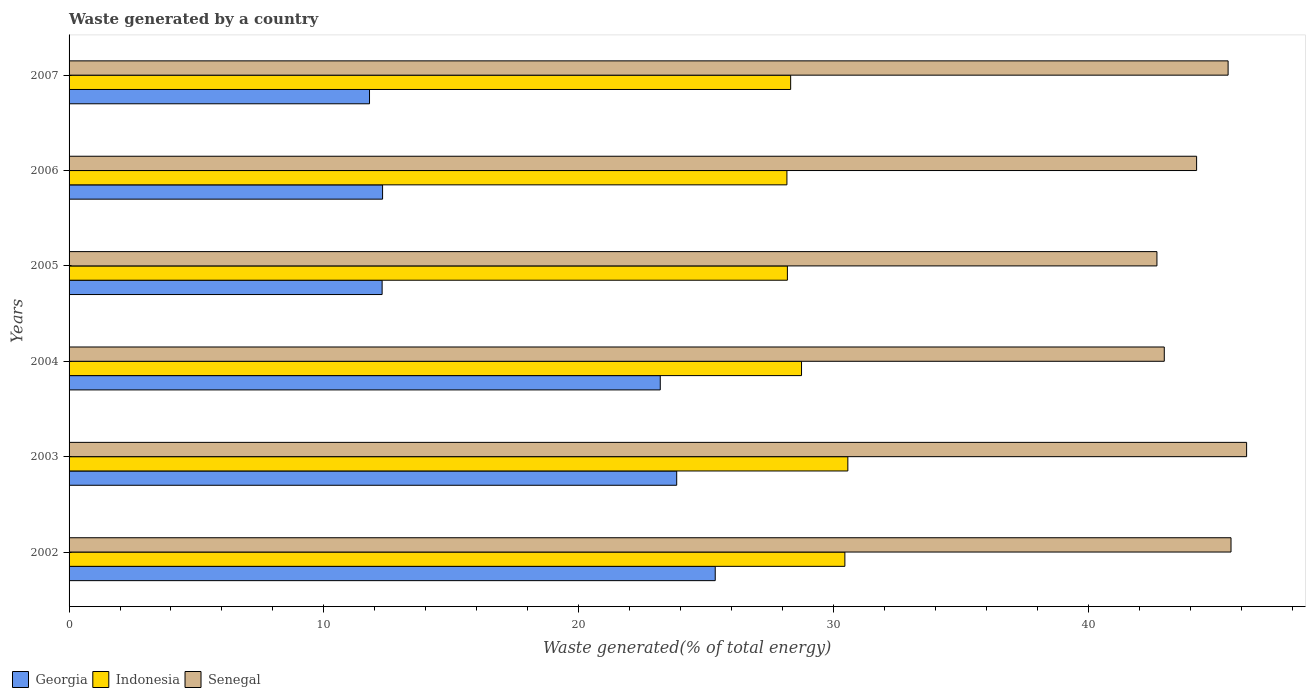Are the number of bars on each tick of the Y-axis equal?
Make the answer very short. Yes. What is the label of the 3rd group of bars from the top?
Provide a short and direct response. 2005. In how many cases, is the number of bars for a given year not equal to the number of legend labels?
Offer a terse response. 0. What is the total waste generated in Georgia in 2003?
Your response must be concise. 23.85. Across all years, what is the maximum total waste generated in Senegal?
Keep it short and to the point. 46.22. Across all years, what is the minimum total waste generated in Indonesia?
Offer a terse response. 28.17. In which year was the total waste generated in Senegal minimum?
Your response must be concise. 2005. What is the total total waste generated in Senegal in the graph?
Make the answer very short. 267.24. What is the difference between the total waste generated in Senegal in 2005 and that in 2007?
Give a very brief answer. -2.79. What is the difference between the total waste generated in Indonesia in 2003 and the total waste generated in Georgia in 2002?
Offer a terse response. 5.2. What is the average total waste generated in Indonesia per year?
Provide a short and direct response. 29.07. In the year 2003, what is the difference between the total waste generated in Indonesia and total waste generated in Senegal?
Give a very brief answer. -15.65. In how many years, is the total waste generated in Indonesia greater than 2 %?
Your answer should be compact. 6. What is the ratio of the total waste generated in Senegal in 2002 to that in 2007?
Provide a succinct answer. 1. Is the difference between the total waste generated in Indonesia in 2002 and 2007 greater than the difference between the total waste generated in Senegal in 2002 and 2007?
Give a very brief answer. Yes. What is the difference between the highest and the second highest total waste generated in Georgia?
Your answer should be compact. 1.51. What is the difference between the highest and the lowest total waste generated in Georgia?
Offer a very short reply. 13.57. In how many years, is the total waste generated in Indonesia greater than the average total waste generated in Indonesia taken over all years?
Your answer should be compact. 2. What does the 3rd bar from the top in 2005 represents?
Ensure brevity in your answer.  Georgia. What does the 3rd bar from the bottom in 2004 represents?
Your answer should be compact. Senegal. Are all the bars in the graph horizontal?
Offer a terse response. Yes. What is the difference between two consecutive major ticks on the X-axis?
Give a very brief answer. 10. Are the values on the major ticks of X-axis written in scientific E-notation?
Make the answer very short. No. Does the graph contain any zero values?
Ensure brevity in your answer.  No. How many legend labels are there?
Offer a terse response. 3. How are the legend labels stacked?
Provide a succinct answer. Horizontal. What is the title of the graph?
Your answer should be very brief. Waste generated by a country. What is the label or title of the X-axis?
Keep it short and to the point. Waste generated(% of total energy). What is the label or title of the Y-axis?
Your answer should be compact. Years. What is the Waste generated(% of total energy) in Georgia in 2002?
Provide a short and direct response. 25.36. What is the Waste generated(% of total energy) in Indonesia in 2002?
Your answer should be compact. 30.45. What is the Waste generated(% of total energy) of Senegal in 2002?
Offer a terse response. 45.6. What is the Waste generated(% of total energy) of Georgia in 2003?
Your response must be concise. 23.85. What is the Waste generated(% of total energy) of Indonesia in 2003?
Make the answer very short. 30.57. What is the Waste generated(% of total energy) in Senegal in 2003?
Offer a very short reply. 46.22. What is the Waste generated(% of total energy) in Georgia in 2004?
Offer a very short reply. 23.2. What is the Waste generated(% of total energy) of Indonesia in 2004?
Offer a very short reply. 28.75. What is the Waste generated(% of total energy) of Senegal in 2004?
Offer a very short reply. 42.99. What is the Waste generated(% of total energy) in Georgia in 2005?
Offer a terse response. 12.29. What is the Waste generated(% of total energy) in Indonesia in 2005?
Offer a very short reply. 28.19. What is the Waste generated(% of total energy) of Senegal in 2005?
Offer a very short reply. 42.7. What is the Waste generated(% of total energy) of Georgia in 2006?
Offer a very short reply. 12.3. What is the Waste generated(% of total energy) in Indonesia in 2006?
Offer a terse response. 28.17. What is the Waste generated(% of total energy) in Senegal in 2006?
Ensure brevity in your answer.  44.25. What is the Waste generated(% of total energy) of Georgia in 2007?
Your answer should be very brief. 11.79. What is the Waste generated(% of total energy) of Indonesia in 2007?
Make the answer very short. 28.32. What is the Waste generated(% of total energy) of Senegal in 2007?
Ensure brevity in your answer.  45.49. Across all years, what is the maximum Waste generated(% of total energy) of Georgia?
Your answer should be compact. 25.36. Across all years, what is the maximum Waste generated(% of total energy) in Indonesia?
Offer a terse response. 30.57. Across all years, what is the maximum Waste generated(% of total energy) of Senegal?
Your response must be concise. 46.22. Across all years, what is the minimum Waste generated(% of total energy) of Georgia?
Ensure brevity in your answer.  11.79. Across all years, what is the minimum Waste generated(% of total energy) in Indonesia?
Offer a very short reply. 28.17. Across all years, what is the minimum Waste generated(% of total energy) of Senegal?
Your answer should be very brief. 42.7. What is the total Waste generated(% of total energy) in Georgia in the graph?
Your answer should be very brief. 108.8. What is the total Waste generated(% of total energy) of Indonesia in the graph?
Keep it short and to the point. 174.45. What is the total Waste generated(% of total energy) in Senegal in the graph?
Ensure brevity in your answer.  267.25. What is the difference between the Waste generated(% of total energy) in Georgia in 2002 and that in 2003?
Ensure brevity in your answer.  1.51. What is the difference between the Waste generated(% of total energy) in Indonesia in 2002 and that in 2003?
Offer a very short reply. -0.12. What is the difference between the Waste generated(% of total energy) in Senegal in 2002 and that in 2003?
Your answer should be very brief. -0.61. What is the difference between the Waste generated(% of total energy) of Georgia in 2002 and that in 2004?
Your answer should be compact. 2.16. What is the difference between the Waste generated(% of total energy) in Indonesia in 2002 and that in 2004?
Provide a succinct answer. 1.7. What is the difference between the Waste generated(% of total energy) in Senegal in 2002 and that in 2004?
Give a very brief answer. 2.62. What is the difference between the Waste generated(% of total energy) in Georgia in 2002 and that in 2005?
Make the answer very short. 13.07. What is the difference between the Waste generated(% of total energy) in Indonesia in 2002 and that in 2005?
Provide a succinct answer. 2.26. What is the difference between the Waste generated(% of total energy) of Senegal in 2002 and that in 2005?
Keep it short and to the point. 2.91. What is the difference between the Waste generated(% of total energy) in Georgia in 2002 and that in 2006?
Provide a succinct answer. 13.06. What is the difference between the Waste generated(% of total energy) in Indonesia in 2002 and that in 2006?
Give a very brief answer. 2.27. What is the difference between the Waste generated(% of total energy) in Senegal in 2002 and that in 2006?
Offer a very short reply. 1.35. What is the difference between the Waste generated(% of total energy) of Georgia in 2002 and that in 2007?
Ensure brevity in your answer.  13.57. What is the difference between the Waste generated(% of total energy) of Indonesia in 2002 and that in 2007?
Keep it short and to the point. 2.13. What is the difference between the Waste generated(% of total energy) in Senegal in 2002 and that in 2007?
Offer a terse response. 0.11. What is the difference between the Waste generated(% of total energy) of Georgia in 2003 and that in 2004?
Make the answer very short. 0.65. What is the difference between the Waste generated(% of total energy) in Indonesia in 2003 and that in 2004?
Keep it short and to the point. 1.82. What is the difference between the Waste generated(% of total energy) of Senegal in 2003 and that in 2004?
Keep it short and to the point. 3.23. What is the difference between the Waste generated(% of total energy) in Georgia in 2003 and that in 2005?
Make the answer very short. 11.56. What is the difference between the Waste generated(% of total energy) in Indonesia in 2003 and that in 2005?
Ensure brevity in your answer.  2.37. What is the difference between the Waste generated(% of total energy) of Senegal in 2003 and that in 2005?
Give a very brief answer. 3.52. What is the difference between the Waste generated(% of total energy) in Georgia in 2003 and that in 2006?
Your answer should be very brief. 11.54. What is the difference between the Waste generated(% of total energy) in Indonesia in 2003 and that in 2006?
Your answer should be very brief. 2.39. What is the difference between the Waste generated(% of total energy) of Senegal in 2003 and that in 2006?
Make the answer very short. 1.96. What is the difference between the Waste generated(% of total energy) of Georgia in 2003 and that in 2007?
Your response must be concise. 12.06. What is the difference between the Waste generated(% of total energy) of Indonesia in 2003 and that in 2007?
Give a very brief answer. 2.24. What is the difference between the Waste generated(% of total energy) in Senegal in 2003 and that in 2007?
Your answer should be compact. 0.73. What is the difference between the Waste generated(% of total energy) in Georgia in 2004 and that in 2005?
Provide a short and direct response. 10.92. What is the difference between the Waste generated(% of total energy) of Indonesia in 2004 and that in 2005?
Make the answer very short. 0.56. What is the difference between the Waste generated(% of total energy) of Senegal in 2004 and that in 2005?
Make the answer very short. 0.29. What is the difference between the Waste generated(% of total energy) of Georgia in 2004 and that in 2006?
Your answer should be compact. 10.9. What is the difference between the Waste generated(% of total energy) in Indonesia in 2004 and that in 2006?
Provide a short and direct response. 0.57. What is the difference between the Waste generated(% of total energy) in Senegal in 2004 and that in 2006?
Ensure brevity in your answer.  -1.27. What is the difference between the Waste generated(% of total energy) of Georgia in 2004 and that in 2007?
Make the answer very short. 11.41. What is the difference between the Waste generated(% of total energy) of Indonesia in 2004 and that in 2007?
Provide a succinct answer. 0.43. What is the difference between the Waste generated(% of total energy) in Senegal in 2004 and that in 2007?
Provide a succinct answer. -2.5. What is the difference between the Waste generated(% of total energy) of Georgia in 2005 and that in 2006?
Give a very brief answer. -0.02. What is the difference between the Waste generated(% of total energy) of Indonesia in 2005 and that in 2006?
Ensure brevity in your answer.  0.02. What is the difference between the Waste generated(% of total energy) in Senegal in 2005 and that in 2006?
Make the answer very short. -1.56. What is the difference between the Waste generated(% of total energy) of Georgia in 2005 and that in 2007?
Ensure brevity in your answer.  0.49. What is the difference between the Waste generated(% of total energy) of Indonesia in 2005 and that in 2007?
Offer a terse response. -0.13. What is the difference between the Waste generated(% of total energy) in Senegal in 2005 and that in 2007?
Your answer should be compact. -2.79. What is the difference between the Waste generated(% of total energy) in Georgia in 2006 and that in 2007?
Offer a terse response. 0.51. What is the difference between the Waste generated(% of total energy) of Indonesia in 2006 and that in 2007?
Your answer should be very brief. -0.15. What is the difference between the Waste generated(% of total energy) of Senegal in 2006 and that in 2007?
Keep it short and to the point. -1.24. What is the difference between the Waste generated(% of total energy) in Georgia in 2002 and the Waste generated(% of total energy) in Indonesia in 2003?
Provide a short and direct response. -5.2. What is the difference between the Waste generated(% of total energy) in Georgia in 2002 and the Waste generated(% of total energy) in Senegal in 2003?
Keep it short and to the point. -20.86. What is the difference between the Waste generated(% of total energy) in Indonesia in 2002 and the Waste generated(% of total energy) in Senegal in 2003?
Provide a short and direct response. -15.77. What is the difference between the Waste generated(% of total energy) in Georgia in 2002 and the Waste generated(% of total energy) in Indonesia in 2004?
Ensure brevity in your answer.  -3.39. What is the difference between the Waste generated(% of total energy) of Georgia in 2002 and the Waste generated(% of total energy) of Senegal in 2004?
Make the answer very short. -17.62. What is the difference between the Waste generated(% of total energy) of Indonesia in 2002 and the Waste generated(% of total energy) of Senegal in 2004?
Ensure brevity in your answer.  -12.54. What is the difference between the Waste generated(% of total energy) in Georgia in 2002 and the Waste generated(% of total energy) in Indonesia in 2005?
Offer a terse response. -2.83. What is the difference between the Waste generated(% of total energy) of Georgia in 2002 and the Waste generated(% of total energy) of Senegal in 2005?
Your answer should be compact. -17.34. What is the difference between the Waste generated(% of total energy) of Indonesia in 2002 and the Waste generated(% of total energy) of Senegal in 2005?
Make the answer very short. -12.25. What is the difference between the Waste generated(% of total energy) in Georgia in 2002 and the Waste generated(% of total energy) in Indonesia in 2006?
Your response must be concise. -2.81. What is the difference between the Waste generated(% of total energy) of Georgia in 2002 and the Waste generated(% of total energy) of Senegal in 2006?
Ensure brevity in your answer.  -18.89. What is the difference between the Waste generated(% of total energy) in Indonesia in 2002 and the Waste generated(% of total energy) in Senegal in 2006?
Your answer should be very brief. -13.8. What is the difference between the Waste generated(% of total energy) in Georgia in 2002 and the Waste generated(% of total energy) in Indonesia in 2007?
Your answer should be very brief. -2.96. What is the difference between the Waste generated(% of total energy) of Georgia in 2002 and the Waste generated(% of total energy) of Senegal in 2007?
Make the answer very short. -20.13. What is the difference between the Waste generated(% of total energy) of Indonesia in 2002 and the Waste generated(% of total energy) of Senegal in 2007?
Give a very brief answer. -15.04. What is the difference between the Waste generated(% of total energy) of Georgia in 2003 and the Waste generated(% of total energy) of Indonesia in 2004?
Your response must be concise. -4.9. What is the difference between the Waste generated(% of total energy) of Georgia in 2003 and the Waste generated(% of total energy) of Senegal in 2004?
Your response must be concise. -19.14. What is the difference between the Waste generated(% of total energy) of Indonesia in 2003 and the Waste generated(% of total energy) of Senegal in 2004?
Ensure brevity in your answer.  -12.42. What is the difference between the Waste generated(% of total energy) in Georgia in 2003 and the Waste generated(% of total energy) in Indonesia in 2005?
Keep it short and to the point. -4.34. What is the difference between the Waste generated(% of total energy) of Georgia in 2003 and the Waste generated(% of total energy) of Senegal in 2005?
Ensure brevity in your answer.  -18.85. What is the difference between the Waste generated(% of total energy) in Indonesia in 2003 and the Waste generated(% of total energy) in Senegal in 2005?
Provide a succinct answer. -12.13. What is the difference between the Waste generated(% of total energy) of Georgia in 2003 and the Waste generated(% of total energy) of Indonesia in 2006?
Your answer should be compact. -4.33. What is the difference between the Waste generated(% of total energy) of Georgia in 2003 and the Waste generated(% of total energy) of Senegal in 2006?
Offer a very short reply. -20.41. What is the difference between the Waste generated(% of total energy) of Indonesia in 2003 and the Waste generated(% of total energy) of Senegal in 2006?
Provide a short and direct response. -13.69. What is the difference between the Waste generated(% of total energy) of Georgia in 2003 and the Waste generated(% of total energy) of Indonesia in 2007?
Give a very brief answer. -4.47. What is the difference between the Waste generated(% of total energy) of Georgia in 2003 and the Waste generated(% of total energy) of Senegal in 2007?
Offer a very short reply. -21.64. What is the difference between the Waste generated(% of total energy) in Indonesia in 2003 and the Waste generated(% of total energy) in Senegal in 2007?
Your answer should be very brief. -14.92. What is the difference between the Waste generated(% of total energy) of Georgia in 2004 and the Waste generated(% of total energy) of Indonesia in 2005?
Make the answer very short. -4.99. What is the difference between the Waste generated(% of total energy) in Georgia in 2004 and the Waste generated(% of total energy) in Senegal in 2005?
Offer a terse response. -19.49. What is the difference between the Waste generated(% of total energy) in Indonesia in 2004 and the Waste generated(% of total energy) in Senegal in 2005?
Your answer should be very brief. -13.95. What is the difference between the Waste generated(% of total energy) in Georgia in 2004 and the Waste generated(% of total energy) in Indonesia in 2006?
Offer a very short reply. -4.97. What is the difference between the Waste generated(% of total energy) in Georgia in 2004 and the Waste generated(% of total energy) in Senegal in 2006?
Offer a very short reply. -21.05. What is the difference between the Waste generated(% of total energy) in Indonesia in 2004 and the Waste generated(% of total energy) in Senegal in 2006?
Keep it short and to the point. -15.51. What is the difference between the Waste generated(% of total energy) of Georgia in 2004 and the Waste generated(% of total energy) of Indonesia in 2007?
Your answer should be compact. -5.12. What is the difference between the Waste generated(% of total energy) of Georgia in 2004 and the Waste generated(% of total energy) of Senegal in 2007?
Offer a terse response. -22.29. What is the difference between the Waste generated(% of total energy) of Indonesia in 2004 and the Waste generated(% of total energy) of Senegal in 2007?
Your answer should be very brief. -16.74. What is the difference between the Waste generated(% of total energy) of Georgia in 2005 and the Waste generated(% of total energy) of Indonesia in 2006?
Offer a terse response. -15.89. What is the difference between the Waste generated(% of total energy) in Georgia in 2005 and the Waste generated(% of total energy) in Senegal in 2006?
Your response must be concise. -31.97. What is the difference between the Waste generated(% of total energy) in Indonesia in 2005 and the Waste generated(% of total energy) in Senegal in 2006?
Provide a succinct answer. -16.06. What is the difference between the Waste generated(% of total energy) of Georgia in 2005 and the Waste generated(% of total energy) of Indonesia in 2007?
Make the answer very short. -16.03. What is the difference between the Waste generated(% of total energy) in Georgia in 2005 and the Waste generated(% of total energy) in Senegal in 2007?
Provide a succinct answer. -33.2. What is the difference between the Waste generated(% of total energy) in Indonesia in 2005 and the Waste generated(% of total energy) in Senegal in 2007?
Provide a short and direct response. -17.3. What is the difference between the Waste generated(% of total energy) in Georgia in 2006 and the Waste generated(% of total energy) in Indonesia in 2007?
Offer a very short reply. -16.02. What is the difference between the Waste generated(% of total energy) of Georgia in 2006 and the Waste generated(% of total energy) of Senegal in 2007?
Make the answer very short. -33.19. What is the difference between the Waste generated(% of total energy) in Indonesia in 2006 and the Waste generated(% of total energy) in Senegal in 2007?
Your response must be concise. -17.32. What is the average Waste generated(% of total energy) in Georgia per year?
Provide a succinct answer. 18.13. What is the average Waste generated(% of total energy) of Indonesia per year?
Keep it short and to the point. 29.07. What is the average Waste generated(% of total energy) in Senegal per year?
Ensure brevity in your answer.  44.54. In the year 2002, what is the difference between the Waste generated(% of total energy) in Georgia and Waste generated(% of total energy) in Indonesia?
Your answer should be compact. -5.09. In the year 2002, what is the difference between the Waste generated(% of total energy) in Georgia and Waste generated(% of total energy) in Senegal?
Your answer should be very brief. -20.24. In the year 2002, what is the difference between the Waste generated(% of total energy) of Indonesia and Waste generated(% of total energy) of Senegal?
Provide a succinct answer. -15.16. In the year 2003, what is the difference between the Waste generated(% of total energy) in Georgia and Waste generated(% of total energy) in Indonesia?
Your response must be concise. -6.72. In the year 2003, what is the difference between the Waste generated(% of total energy) in Georgia and Waste generated(% of total energy) in Senegal?
Ensure brevity in your answer.  -22.37. In the year 2003, what is the difference between the Waste generated(% of total energy) in Indonesia and Waste generated(% of total energy) in Senegal?
Give a very brief answer. -15.65. In the year 2004, what is the difference between the Waste generated(% of total energy) in Georgia and Waste generated(% of total energy) in Indonesia?
Ensure brevity in your answer.  -5.54. In the year 2004, what is the difference between the Waste generated(% of total energy) of Georgia and Waste generated(% of total energy) of Senegal?
Offer a terse response. -19.78. In the year 2004, what is the difference between the Waste generated(% of total energy) of Indonesia and Waste generated(% of total energy) of Senegal?
Your response must be concise. -14.24. In the year 2005, what is the difference between the Waste generated(% of total energy) in Georgia and Waste generated(% of total energy) in Indonesia?
Provide a succinct answer. -15.91. In the year 2005, what is the difference between the Waste generated(% of total energy) of Georgia and Waste generated(% of total energy) of Senegal?
Your response must be concise. -30.41. In the year 2005, what is the difference between the Waste generated(% of total energy) of Indonesia and Waste generated(% of total energy) of Senegal?
Your response must be concise. -14.5. In the year 2006, what is the difference between the Waste generated(% of total energy) in Georgia and Waste generated(% of total energy) in Indonesia?
Make the answer very short. -15.87. In the year 2006, what is the difference between the Waste generated(% of total energy) in Georgia and Waste generated(% of total energy) in Senegal?
Make the answer very short. -31.95. In the year 2006, what is the difference between the Waste generated(% of total energy) in Indonesia and Waste generated(% of total energy) in Senegal?
Provide a succinct answer. -16.08. In the year 2007, what is the difference between the Waste generated(% of total energy) of Georgia and Waste generated(% of total energy) of Indonesia?
Provide a short and direct response. -16.53. In the year 2007, what is the difference between the Waste generated(% of total energy) in Georgia and Waste generated(% of total energy) in Senegal?
Your answer should be compact. -33.7. In the year 2007, what is the difference between the Waste generated(% of total energy) of Indonesia and Waste generated(% of total energy) of Senegal?
Keep it short and to the point. -17.17. What is the ratio of the Waste generated(% of total energy) of Georgia in 2002 to that in 2003?
Offer a terse response. 1.06. What is the ratio of the Waste generated(% of total energy) of Indonesia in 2002 to that in 2003?
Ensure brevity in your answer.  1. What is the ratio of the Waste generated(% of total energy) of Senegal in 2002 to that in 2003?
Your answer should be very brief. 0.99. What is the ratio of the Waste generated(% of total energy) in Georgia in 2002 to that in 2004?
Your answer should be compact. 1.09. What is the ratio of the Waste generated(% of total energy) in Indonesia in 2002 to that in 2004?
Offer a terse response. 1.06. What is the ratio of the Waste generated(% of total energy) of Senegal in 2002 to that in 2004?
Make the answer very short. 1.06. What is the ratio of the Waste generated(% of total energy) in Georgia in 2002 to that in 2005?
Offer a very short reply. 2.06. What is the ratio of the Waste generated(% of total energy) in Indonesia in 2002 to that in 2005?
Your answer should be compact. 1.08. What is the ratio of the Waste generated(% of total energy) in Senegal in 2002 to that in 2005?
Your answer should be very brief. 1.07. What is the ratio of the Waste generated(% of total energy) in Georgia in 2002 to that in 2006?
Provide a succinct answer. 2.06. What is the ratio of the Waste generated(% of total energy) of Indonesia in 2002 to that in 2006?
Make the answer very short. 1.08. What is the ratio of the Waste generated(% of total energy) of Senegal in 2002 to that in 2006?
Offer a very short reply. 1.03. What is the ratio of the Waste generated(% of total energy) in Georgia in 2002 to that in 2007?
Your answer should be compact. 2.15. What is the ratio of the Waste generated(% of total energy) of Indonesia in 2002 to that in 2007?
Make the answer very short. 1.08. What is the ratio of the Waste generated(% of total energy) in Georgia in 2003 to that in 2004?
Your answer should be very brief. 1.03. What is the ratio of the Waste generated(% of total energy) of Indonesia in 2003 to that in 2004?
Give a very brief answer. 1.06. What is the ratio of the Waste generated(% of total energy) in Senegal in 2003 to that in 2004?
Keep it short and to the point. 1.08. What is the ratio of the Waste generated(% of total energy) of Georgia in 2003 to that in 2005?
Offer a very short reply. 1.94. What is the ratio of the Waste generated(% of total energy) in Indonesia in 2003 to that in 2005?
Your answer should be compact. 1.08. What is the ratio of the Waste generated(% of total energy) in Senegal in 2003 to that in 2005?
Your response must be concise. 1.08. What is the ratio of the Waste generated(% of total energy) of Georgia in 2003 to that in 2006?
Your answer should be very brief. 1.94. What is the ratio of the Waste generated(% of total energy) of Indonesia in 2003 to that in 2006?
Your answer should be compact. 1.08. What is the ratio of the Waste generated(% of total energy) in Senegal in 2003 to that in 2006?
Offer a terse response. 1.04. What is the ratio of the Waste generated(% of total energy) of Georgia in 2003 to that in 2007?
Offer a very short reply. 2.02. What is the ratio of the Waste generated(% of total energy) in Indonesia in 2003 to that in 2007?
Give a very brief answer. 1.08. What is the ratio of the Waste generated(% of total energy) in Senegal in 2003 to that in 2007?
Provide a short and direct response. 1.02. What is the ratio of the Waste generated(% of total energy) of Georgia in 2004 to that in 2005?
Provide a short and direct response. 1.89. What is the ratio of the Waste generated(% of total energy) in Indonesia in 2004 to that in 2005?
Make the answer very short. 1.02. What is the ratio of the Waste generated(% of total energy) in Senegal in 2004 to that in 2005?
Your answer should be compact. 1.01. What is the ratio of the Waste generated(% of total energy) of Georgia in 2004 to that in 2006?
Offer a very short reply. 1.89. What is the ratio of the Waste generated(% of total energy) of Indonesia in 2004 to that in 2006?
Offer a terse response. 1.02. What is the ratio of the Waste generated(% of total energy) of Senegal in 2004 to that in 2006?
Your answer should be compact. 0.97. What is the ratio of the Waste generated(% of total energy) of Georgia in 2004 to that in 2007?
Offer a terse response. 1.97. What is the ratio of the Waste generated(% of total energy) in Indonesia in 2004 to that in 2007?
Ensure brevity in your answer.  1.02. What is the ratio of the Waste generated(% of total energy) of Senegal in 2004 to that in 2007?
Your response must be concise. 0.94. What is the ratio of the Waste generated(% of total energy) in Georgia in 2005 to that in 2006?
Offer a terse response. 1. What is the ratio of the Waste generated(% of total energy) of Senegal in 2005 to that in 2006?
Your response must be concise. 0.96. What is the ratio of the Waste generated(% of total energy) of Georgia in 2005 to that in 2007?
Make the answer very short. 1.04. What is the ratio of the Waste generated(% of total energy) in Indonesia in 2005 to that in 2007?
Your answer should be compact. 1. What is the ratio of the Waste generated(% of total energy) in Senegal in 2005 to that in 2007?
Offer a terse response. 0.94. What is the ratio of the Waste generated(% of total energy) in Georgia in 2006 to that in 2007?
Make the answer very short. 1.04. What is the ratio of the Waste generated(% of total energy) in Senegal in 2006 to that in 2007?
Provide a succinct answer. 0.97. What is the difference between the highest and the second highest Waste generated(% of total energy) of Georgia?
Offer a very short reply. 1.51. What is the difference between the highest and the second highest Waste generated(% of total energy) in Indonesia?
Your response must be concise. 0.12. What is the difference between the highest and the second highest Waste generated(% of total energy) in Senegal?
Ensure brevity in your answer.  0.61. What is the difference between the highest and the lowest Waste generated(% of total energy) of Georgia?
Offer a very short reply. 13.57. What is the difference between the highest and the lowest Waste generated(% of total energy) in Indonesia?
Offer a terse response. 2.39. What is the difference between the highest and the lowest Waste generated(% of total energy) in Senegal?
Make the answer very short. 3.52. 